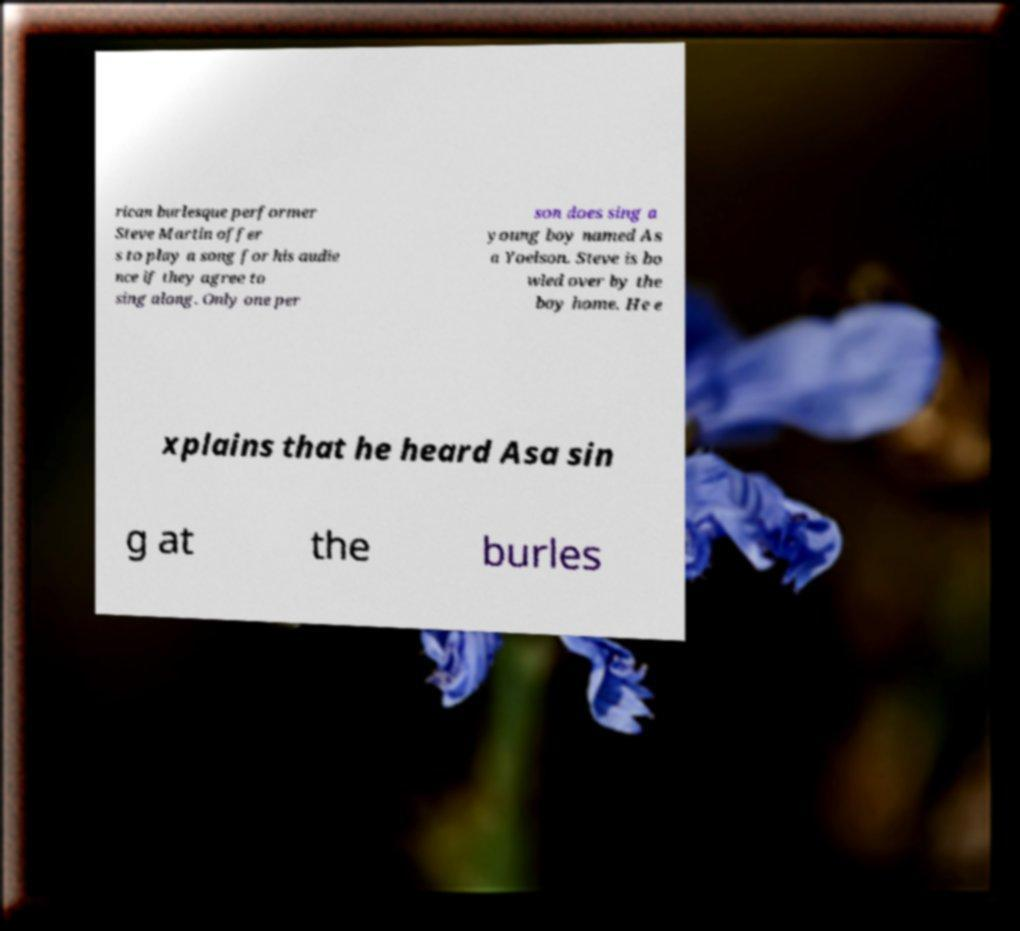Can you accurately transcribe the text from the provided image for me? rican burlesque performer Steve Martin offer s to play a song for his audie nce if they agree to sing along. Only one per son does sing a young boy named As a Yoelson. Steve is bo wled over by the boy home. He e xplains that he heard Asa sin g at the burles 